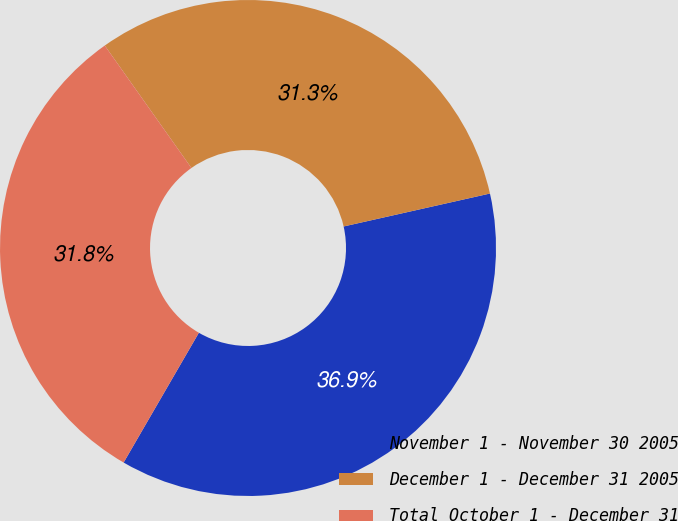Convert chart to OTSL. <chart><loc_0><loc_0><loc_500><loc_500><pie_chart><fcel>November 1 - November 30 2005<fcel>December 1 - December 31 2005<fcel>Total October 1 - December 31<nl><fcel>36.89%<fcel>31.28%<fcel>31.84%<nl></chart> 